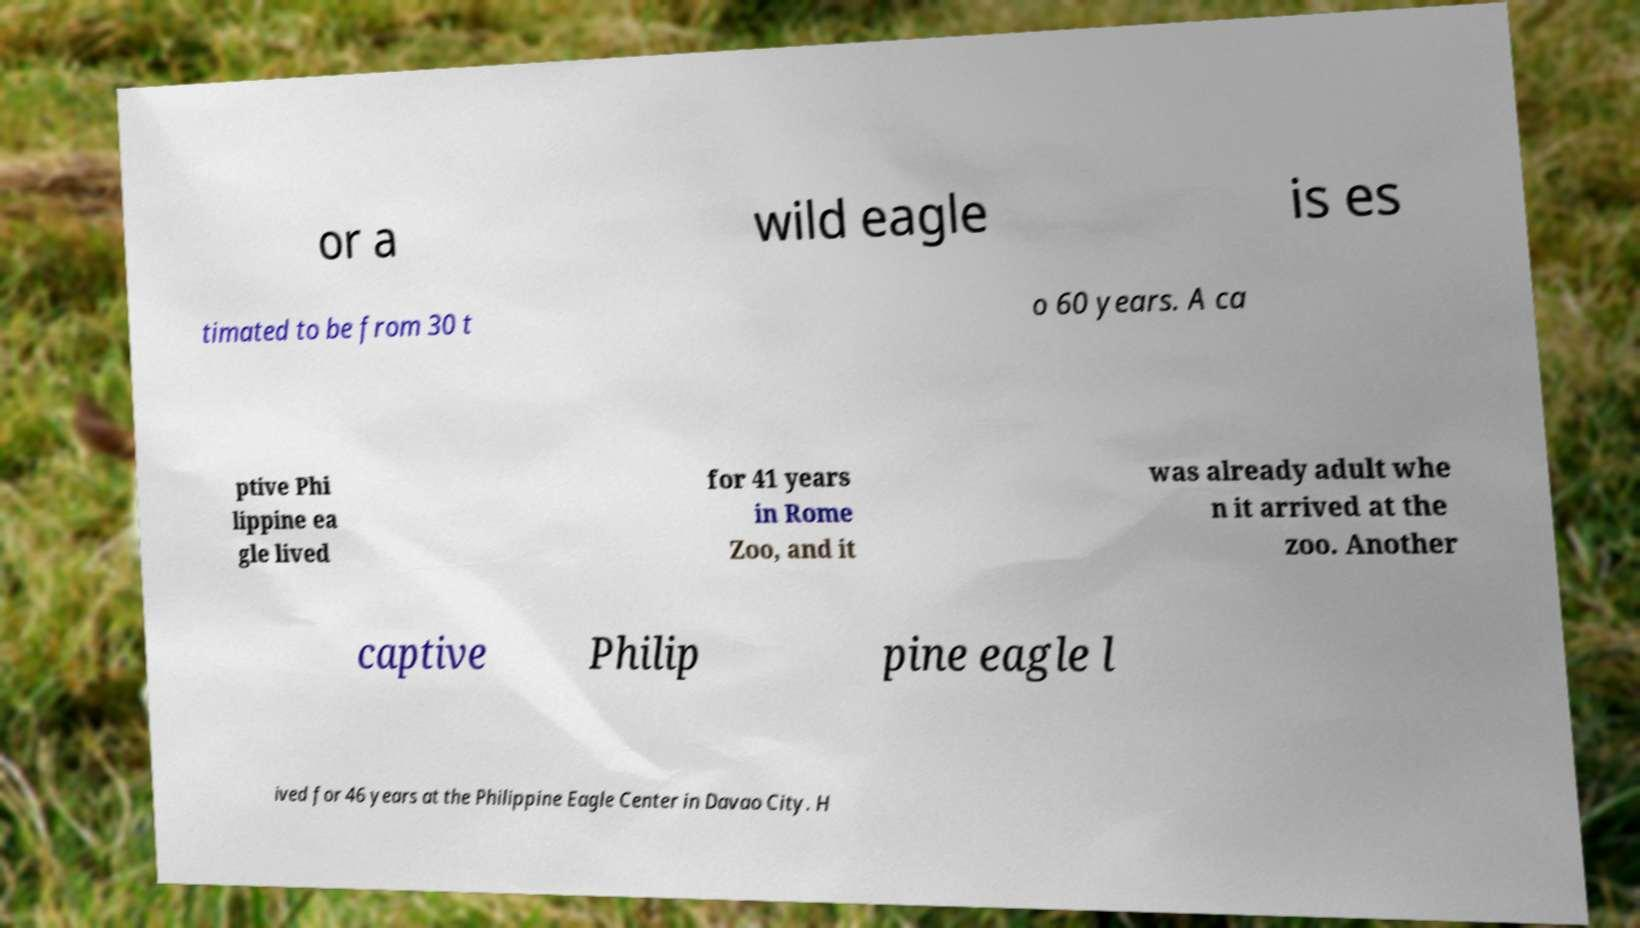There's text embedded in this image that I need extracted. Can you transcribe it verbatim? or a wild eagle is es timated to be from 30 t o 60 years. A ca ptive Phi lippine ea gle lived for 41 years in Rome Zoo, and it was already adult whe n it arrived at the zoo. Another captive Philip pine eagle l ived for 46 years at the Philippine Eagle Center in Davao City. H 